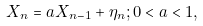Convert formula to latex. <formula><loc_0><loc_0><loc_500><loc_500>X _ { n } = a X _ { n - 1 } + \eta _ { n } ; 0 < a < 1 ,</formula> 